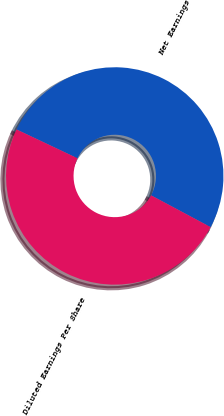<chart> <loc_0><loc_0><loc_500><loc_500><pie_chart><fcel>Net Earnings<fcel>Diluted Earnings Per Share<nl><fcel>50.77%<fcel>49.23%<nl></chart> 